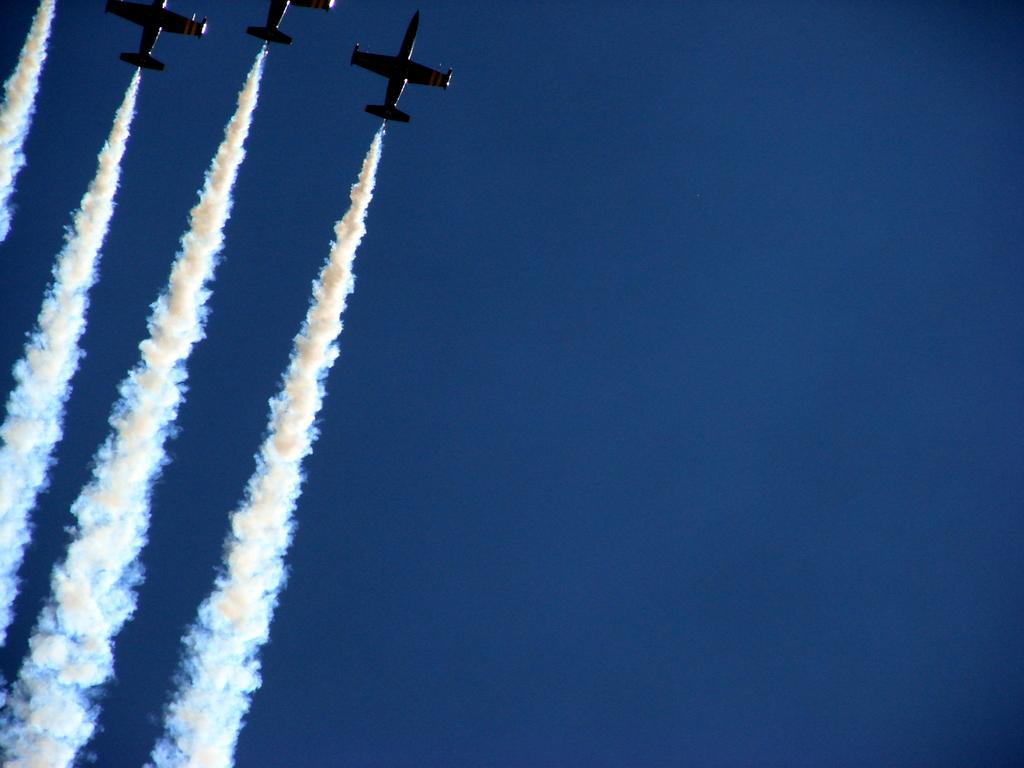How many aircraft are present in the image? There are four aircraft in the image. What are the aircraft doing in the image? The aircraft are releasing smoke in the image. Where is the smoke visible in the image? The smoke is visible in the sky in the image. What is the color of the sky in the image? The sky is blue in color in the image. Can you see a monkey swinging on a cable in the image? No, there is no monkey or cable present in the image. What scientific discovery is being made in the image? There is no scientific discovery being made in the image; it features four aircraft releasing smoke in the sky. 